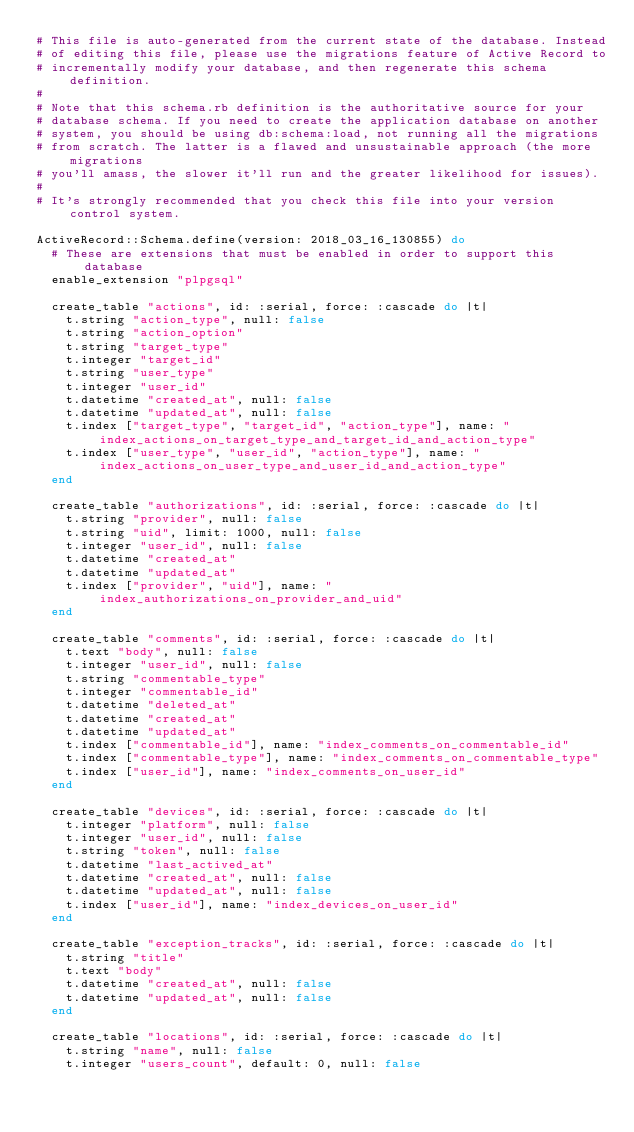<code> <loc_0><loc_0><loc_500><loc_500><_Ruby_># This file is auto-generated from the current state of the database. Instead
# of editing this file, please use the migrations feature of Active Record to
# incrementally modify your database, and then regenerate this schema definition.
#
# Note that this schema.rb definition is the authoritative source for your
# database schema. If you need to create the application database on another
# system, you should be using db:schema:load, not running all the migrations
# from scratch. The latter is a flawed and unsustainable approach (the more migrations
# you'll amass, the slower it'll run and the greater likelihood for issues).
#
# It's strongly recommended that you check this file into your version control system.

ActiveRecord::Schema.define(version: 2018_03_16_130855) do
  # These are extensions that must be enabled in order to support this database
  enable_extension "plpgsql"

  create_table "actions", id: :serial, force: :cascade do |t|
    t.string "action_type", null: false
    t.string "action_option"
    t.string "target_type"
    t.integer "target_id"
    t.string "user_type"
    t.integer "user_id"
    t.datetime "created_at", null: false
    t.datetime "updated_at", null: false
    t.index ["target_type", "target_id", "action_type"], name: "index_actions_on_target_type_and_target_id_and_action_type"
    t.index ["user_type", "user_id", "action_type"], name: "index_actions_on_user_type_and_user_id_and_action_type"
  end

  create_table "authorizations", id: :serial, force: :cascade do |t|
    t.string "provider", null: false
    t.string "uid", limit: 1000, null: false
    t.integer "user_id", null: false
    t.datetime "created_at"
    t.datetime "updated_at"
    t.index ["provider", "uid"], name: "index_authorizations_on_provider_and_uid"
  end

  create_table "comments", id: :serial, force: :cascade do |t|
    t.text "body", null: false
    t.integer "user_id", null: false
    t.string "commentable_type"
    t.integer "commentable_id"
    t.datetime "deleted_at"
    t.datetime "created_at"
    t.datetime "updated_at"
    t.index ["commentable_id"], name: "index_comments_on_commentable_id"
    t.index ["commentable_type"], name: "index_comments_on_commentable_type"
    t.index ["user_id"], name: "index_comments_on_user_id"
  end

  create_table "devices", id: :serial, force: :cascade do |t|
    t.integer "platform", null: false
    t.integer "user_id", null: false
    t.string "token", null: false
    t.datetime "last_actived_at"
    t.datetime "created_at", null: false
    t.datetime "updated_at", null: false
    t.index ["user_id"], name: "index_devices_on_user_id"
  end

  create_table "exception_tracks", id: :serial, force: :cascade do |t|
    t.string "title"
    t.text "body"
    t.datetime "created_at", null: false
    t.datetime "updated_at", null: false
  end

  create_table "locations", id: :serial, force: :cascade do |t|
    t.string "name", null: false
    t.integer "users_count", default: 0, null: false</code> 